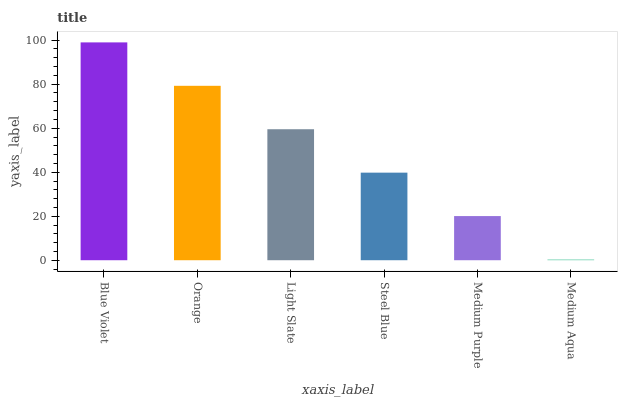Is Medium Aqua the minimum?
Answer yes or no. Yes. Is Blue Violet the maximum?
Answer yes or no. Yes. Is Orange the minimum?
Answer yes or no. No. Is Orange the maximum?
Answer yes or no. No. Is Blue Violet greater than Orange?
Answer yes or no. Yes. Is Orange less than Blue Violet?
Answer yes or no. Yes. Is Orange greater than Blue Violet?
Answer yes or no. No. Is Blue Violet less than Orange?
Answer yes or no. No. Is Light Slate the high median?
Answer yes or no. Yes. Is Steel Blue the low median?
Answer yes or no. Yes. Is Medium Purple the high median?
Answer yes or no. No. Is Medium Aqua the low median?
Answer yes or no. No. 